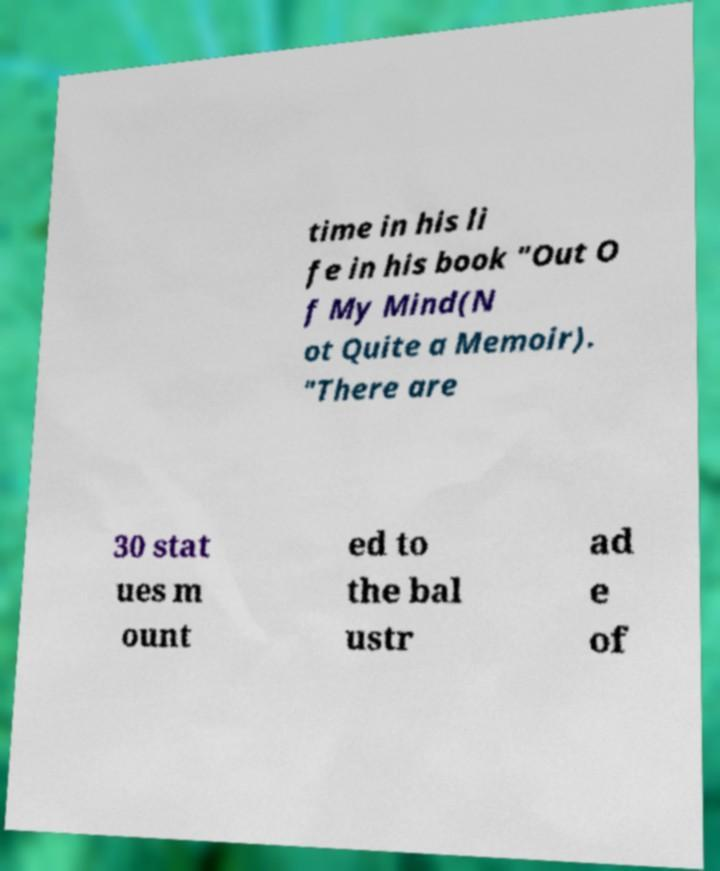Please read and relay the text visible in this image. What does it say? time in his li fe in his book "Out O f My Mind(N ot Quite a Memoir). "There are 30 stat ues m ount ed to the bal ustr ad e of 